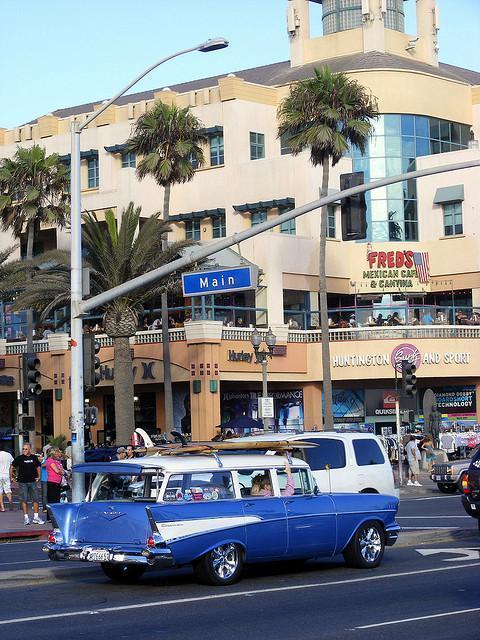How many cars can be seen?
Give a very brief answer. 2. 